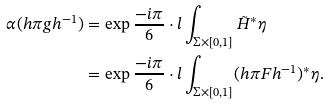<formula> <loc_0><loc_0><loc_500><loc_500>\alpha ( h \pi g h ^ { - 1 } ) & = \exp \frac { - i \pi } { 6 } \cdot l \int _ { \Sigma \times [ 0 , 1 ] } \tilde { H } ^ { * } \eta \\ & = \exp \frac { - i \pi } { 6 } \cdot l \int _ { \Sigma \times [ 0 , 1 ] } ( h \pi F h ^ { - 1 } ) ^ { * } \eta .</formula> 